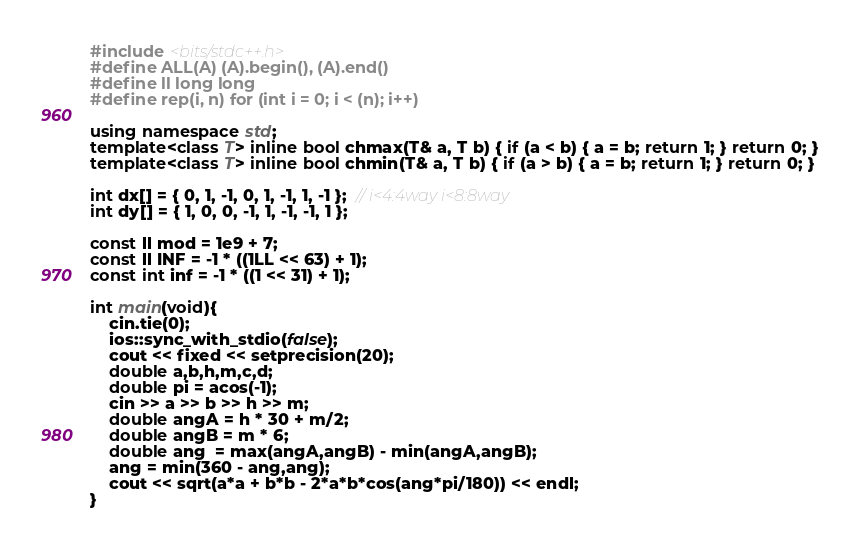<code> <loc_0><loc_0><loc_500><loc_500><_C++_>#include <bits/stdc++.h>
#define ALL(A) (A).begin(), (A).end()
#define ll long long
#define rep(i, n) for (int i = 0; i < (n); i++)

using namespace std;
template<class T> inline bool chmax(T& a, T b) { if (a < b) { a = b; return 1; } return 0; }
template<class T> inline bool chmin(T& a, T b) { if (a > b) { a = b; return 1; } return 0; }

int dx[] = { 0, 1, -1, 0, 1, -1, 1, -1 };  // i<4:4way i<8:8way
int dy[] = { 1, 0, 0, -1, 1, -1, -1, 1 };

const ll mod = 1e9 + 7;
const ll INF = -1 * ((1LL << 63) + 1);
const int inf = -1 * ((1 << 31) + 1);

int main(void){
    cin.tie(0);
    ios::sync_with_stdio(false);
    cout << fixed << setprecision(20);
    double a,b,h,m,c,d;
    double pi = acos(-1);
    cin >> a >> b >> h >> m;
    double angA = h * 30 + m/2;
    double angB = m * 6;
    double ang  = max(angA,angB) - min(angA,angB);
    ang = min(360 - ang,ang);
    cout << sqrt(a*a + b*b - 2*a*b*cos(ang*pi/180)) << endl;
}</code> 